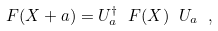Convert formula to latex. <formula><loc_0><loc_0><loc_500><loc_500>F ( X + a ) = U ^ { \dag } _ { a } \ F ( X ) \ U _ { a } \ ,</formula> 